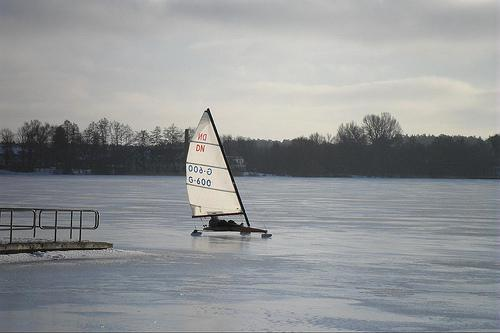Question: what is in the photo?
Choices:
A. Cruise ship.
B. Row boat.
C. Sailboat.
D. Motorboat.
Answer with the letter. Answer: C Question: what color is the sail?
Choices:
A. Red.
B. White.
C. Yellow.
D. Green.
Answer with the letter. Answer: B Question: what is in the background?
Choices:
A. Flowers.
B. Trees.
C. Bushes.
D. Potted plants.
Answer with the letter. Answer: B Question: where is the sailboat?
Choices:
A. River.
B. Lake.
C. Ocean.
D. Lagoon.
Answer with the letter. Answer: B Question: when was the photo taken?
Choices:
A. Sunrise.
B. Dawn.
C. Dusk.
D. Sunset.
Answer with the letter. Answer: C Question: how many people can be seen?
Choices:
A. One.
B. Zero.
C. Two.
D. Three.
Answer with the letter. Answer: B 